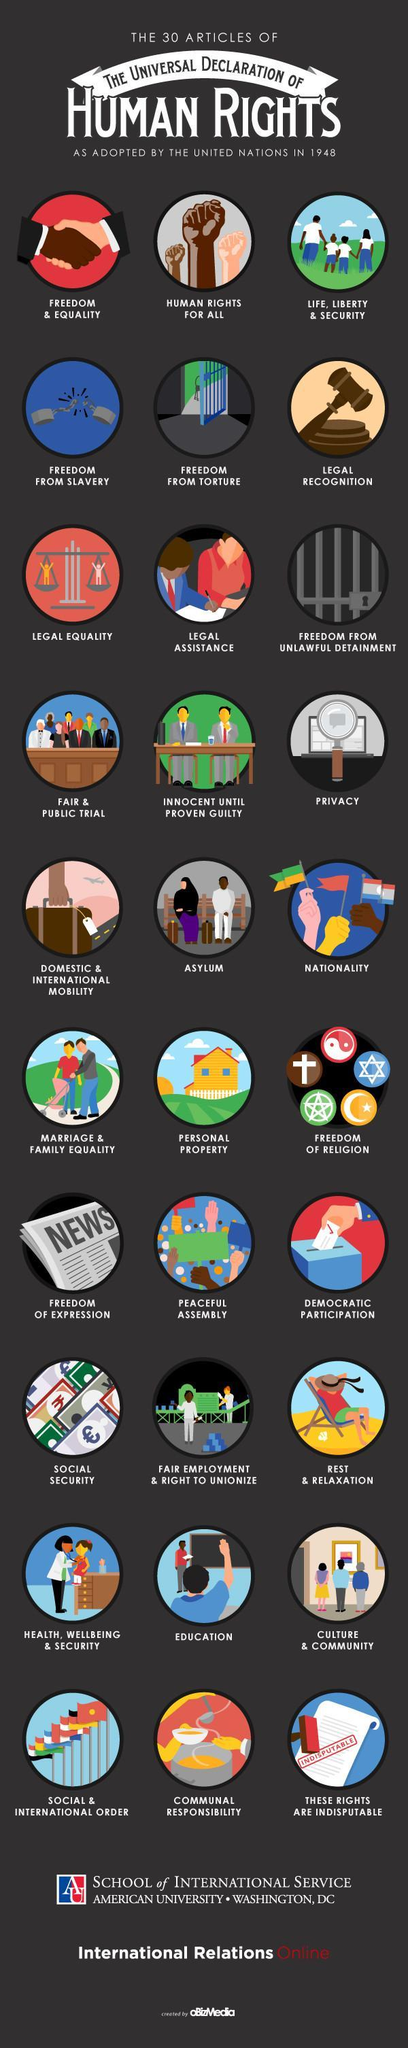What is the 26th article of the universal declaration of human rights as adopted by the united nations in 1948 according to the infographic?
Answer the question with a short phrase. education What is the 20th article of the universal declaration of human rights as adopted by the united nations in 1948 according to the infographic? peaceful assembly What is the 15th article of the universal declaration of human rights as adopted by the united nations in 1948 according to the infographic? Nationality What is the 7th article of the universal declaration of human rights as adopted by the united nations in 1948 according to the infographic? legal equality What is the 18th article of the universal declaration of human rights as adopted by the united nations in 1948 according to the infographic? freedom of religion What is the 29th article of the universal declaration of human rights as adopted by the united nations in 1948 according to the infographic? Communal responsibility 